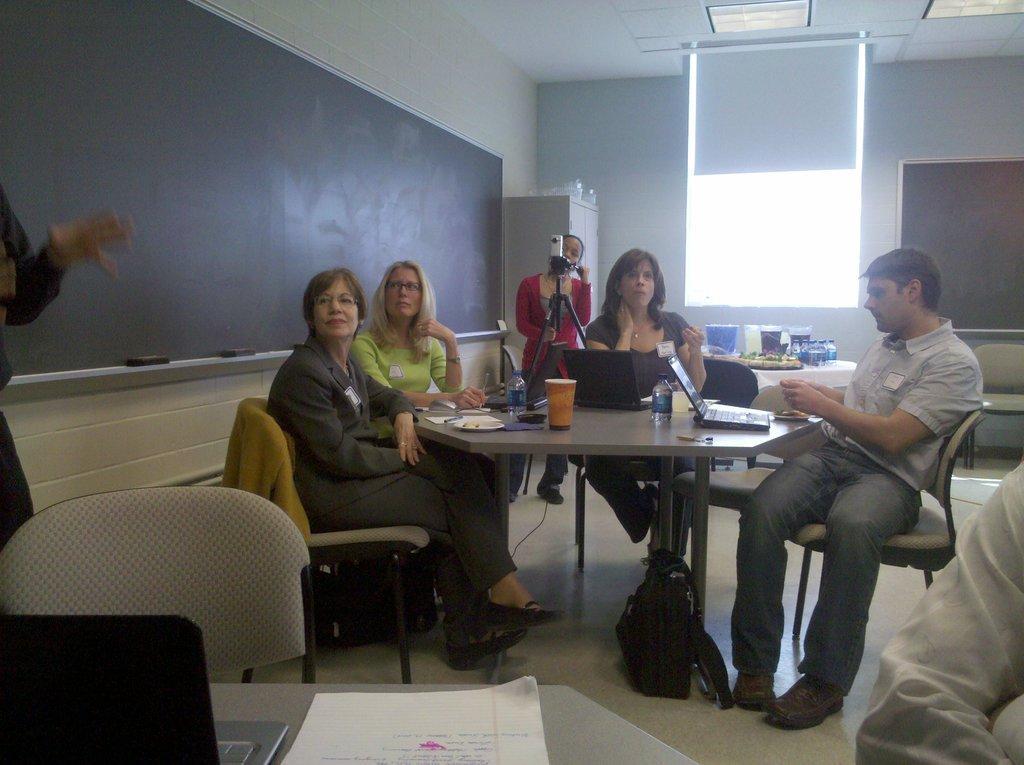How would you summarize this image in a sentence or two? In this image I can see there are group of people who are sitting on a chair in front of the table. On the table we have laptop and other objects on it. On the left side of the image we have a blackboard on the wall. 